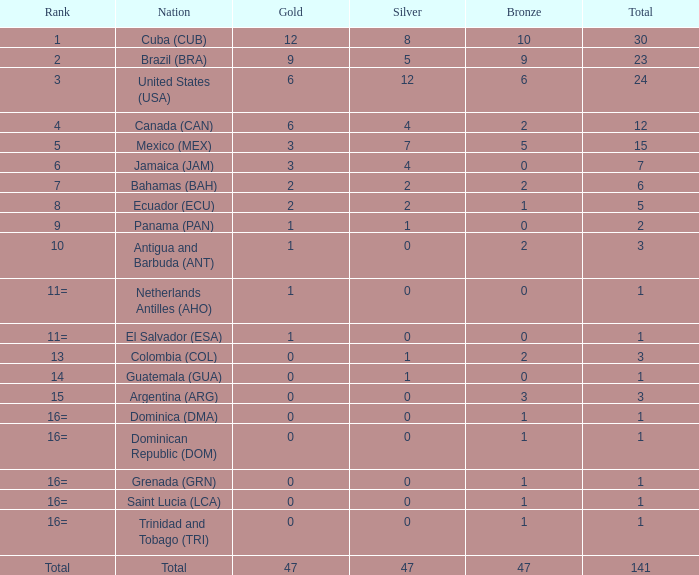What is the standard silver with more than 0 gold, a rank of 1, and a total under 30? None. 